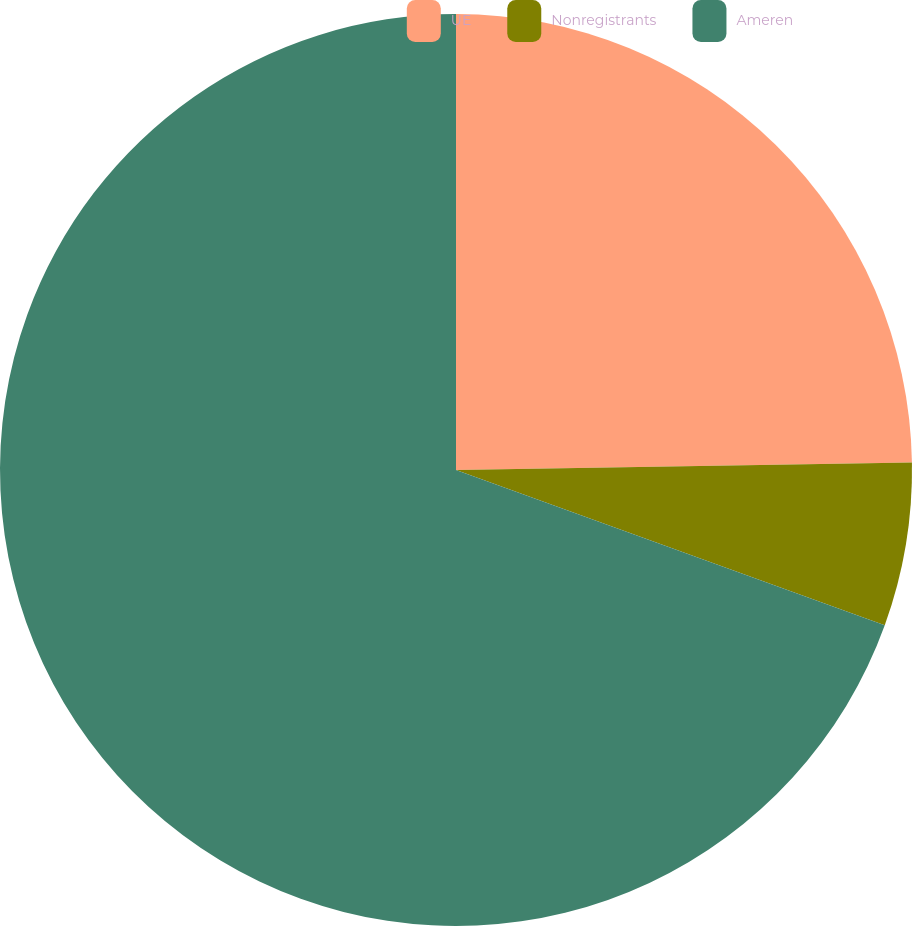Convert chart to OTSL. <chart><loc_0><loc_0><loc_500><loc_500><pie_chart><fcel>UE<fcel>Nonregistrants<fcel>Ameren<nl><fcel>24.74%<fcel>5.79%<fcel>69.47%<nl></chart> 